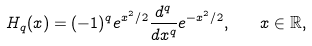<formula> <loc_0><loc_0><loc_500><loc_500>H _ { q } ( x ) = ( - 1 ) ^ { q } e ^ { x ^ { 2 } / 2 } \frac { d ^ { q } } { d x ^ { q } } e ^ { - x ^ { 2 } / 2 } , \quad x \in \mathbb { R } ,</formula> 